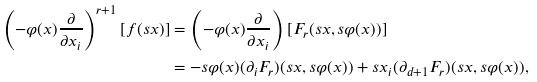Convert formula to latex. <formula><loc_0><loc_0><loc_500><loc_500>\left ( - \varphi ( x ) \frac { \partial } { \partial x _ { i } } \right ) ^ { r + 1 } [ f ( s x ) ] & = \left ( - \varphi ( x ) \frac { \partial } { \partial x _ { i } } \right ) [ F _ { r } ( s x , s \varphi ( x ) ) ] \\ & = - s \varphi ( x ) ( \partial _ { i } F _ { r } ) ( s x , s \varphi ( x ) ) + s x _ { i } ( \partial _ { d + 1 } F _ { r } ) ( s x , s \varphi ( x ) ) ,</formula> 